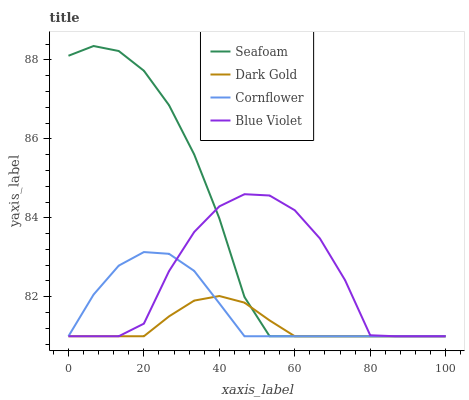Does Dark Gold have the minimum area under the curve?
Answer yes or no. Yes. Does Seafoam have the maximum area under the curve?
Answer yes or no. Yes. Does Blue Violet have the minimum area under the curve?
Answer yes or no. No. Does Blue Violet have the maximum area under the curve?
Answer yes or no. No. Is Dark Gold the smoothest?
Answer yes or no. Yes. Is Blue Violet the roughest?
Answer yes or no. Yes. Is Seafoam the smoothest?
Answer yes or no. No. Is Seafoam the roughest?
Answer yes or no. No. Does Cornflower have the lowest value?
Answer yes or no. Yes. Does Seafoam have the highest value?
Answer yes or no. Yes. Does Blue Violet have the highest value?
Answer yes or no. No. Does Seafoam intersect Dark Gold?
Answer yes or no. Yes. Is Seafoam less than Dark Gold?
Answer yes or no. No. Is Seafoam greater than Dark Gold?
Answer yes or no. No. 